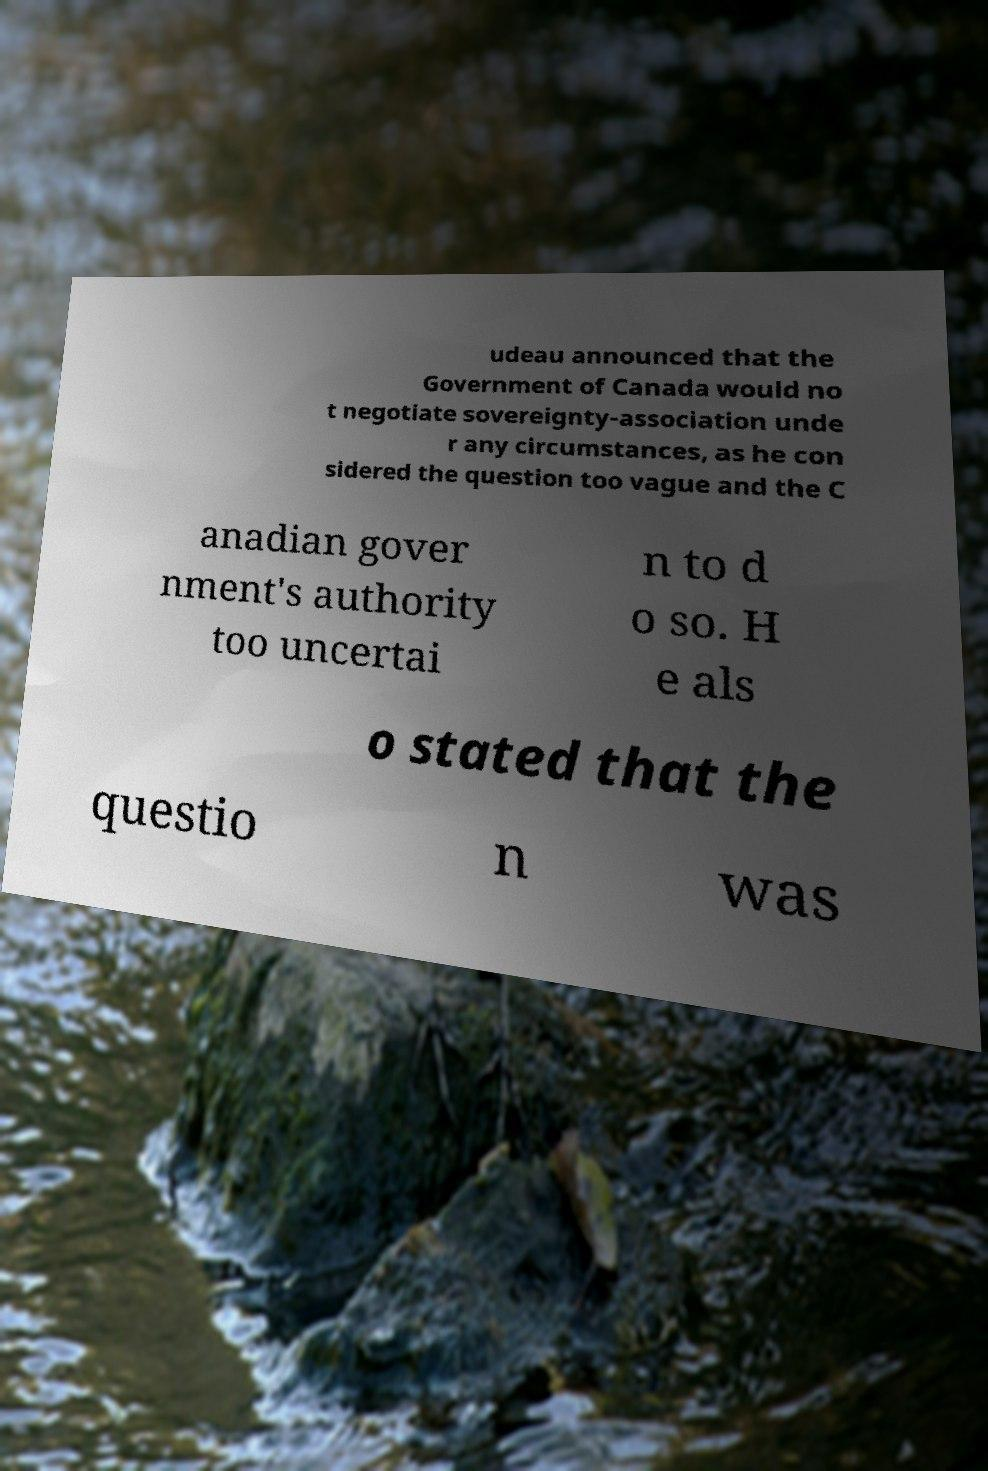Please read and relay the text visible in this image. What does it say? udeau announced that the Government of Canada would no t negotiate sovereignty-association unde r any circumstances, as he con sidered the question too vague and the C anadian gover nment's authority too uncertai n to d o so. H e als o stated that the questio n was 